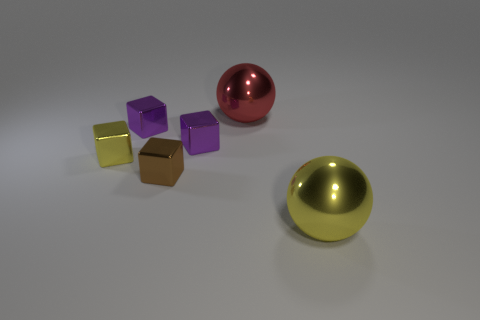There is a object that is the same size as the red ball; what color is it?
Your answer should be very brief. Yellow. How many metal objects are on the left side of the ball left of the yellow ball?
Your answer should be compact. 4. How many big metal spheres are both on the right side of the large red metal thing and behind the tiny yellow shiny block?
Your answer should be compact. 0. How many objects are large metallic balls behind the brown metallic cube or purple things that are right of the brown metallic block?
Make the answer very short. 2. What number of other things are the same size as the brown block?
Give a very brief answer. 3. What shape is the purple metal thing to the left of the small shiny object that is in front of the tiny yellow metallic object?
Your answer should be very brief. Cube. There is a metal block in front of the tiny yellow metal thing; is it the same color as the shiny ball in front of the tiny yellow shiny cube?
Your answer should be very brief. No. Is there a ball?
Offer a terse response. Yes. Are there any balls behind the large red metallic object?
Your answer should be compact. No. There is a yellow thing that is the same shape as the red metal thing; what is its material?
Keep it short and to the point. Metal. 